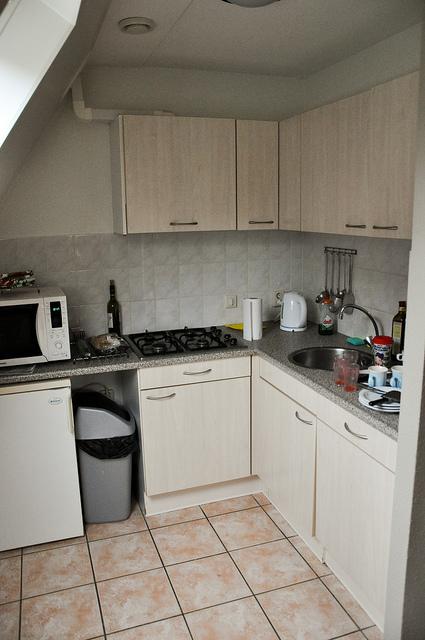Do the cabinets open?
Write a very short answer. Yes. What color is the microwave?
Concise answer only. White. What color plate is on top of the microwave?
Quick response, please. Black. What number of knobs are on the oven?
Write a very short answer. 4. Where is the trash bin?
Concise answer only. Under counter. Is the a mat on the floor?
Write a very short answer. No. Is there natural light in the room?
Quick response, please. Yes. Is the light on?
Keep it brief. No. 